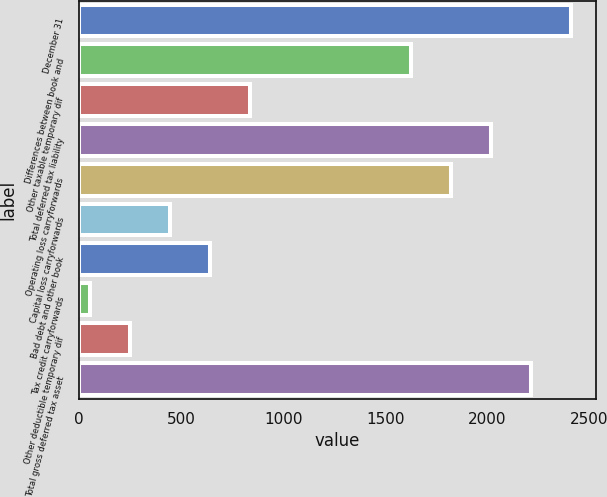Convert chart to OTSL. <chart><loc_0><loc_0><loc_500><loc_500><bar_chart><fcel>December 31<fcel>Differences between book and<fcel>Other taxable temporary dif<fcel>Total deferred tax liability<fcel>Operating loss carryforwards<fcel>Capital loss carryforwards<fcel>Bad debt and other book<fcel>Tax credit carryforwards<fcel>Other deductible temporary dif<fcel>Total gross deferred tax asset<nl><fcel>2410.2<fcel>1623.8<fcel>837.4<fcel>2017<fcel>1820.4<fcel>444.2<fcel>640.8<fcel>51<fcel>247.6<fcel>2213.6<nl></chart> 